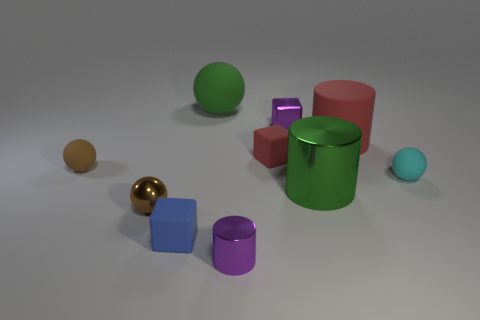Are there any other things that are the same size as the brown rubber object?
Offer a terse response. Yes. What color is the big object that is made of the same material as the purple cylinder?
Offer a very short reply. Green. There is a rubber object on the left side of the shiny ball; is it the same color as the matte sphere behind the large red rubber cylinder?
Your response must be concise. No. How many spheres are either small objects or large things?
Make the answer very short. 4. Are there the same number of tiny cyan rubber objects that are to the left of the red rubber cylinder and large red objects?
Give a very brief answer. No. There is a ball in front of the big green thing that is in front of the purple metallic thing that is on the right side of the tiny red matte block; what is its material?
Give a very brief answer. Metal. What is the material of the other thing that is the same color as the big metal object?
Your answer should be very brief. Rubber. How many objects are either spheres on the right side of the green cylinder or big green cylinders?
Your answer should be compact. 2. What number of objects are either red matte things or tiny brown balls that are in front of the cyan rubber thing?
Give a very brief answer. 3. There is a small rubber thing in front of the tiny metallic thing to the left of the small purple cylinder; how many small purple metal cubes are in front of it?
Ensure brevity in your answer.  0. 